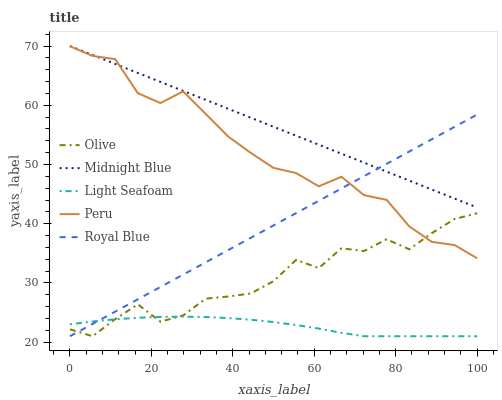Does Light Seafoam have the minimum area under the curve?
Answer yes or no. Yes. Does Midnight Blue have the maximum area under the curve?
Answer yes or no. Yes. Does Royal Blue have the minimum area under the curve?
Answer yes or no. No. Does Royal Blue have the maximum area under the curve?
Answer yes or no. No. Is Royal Blue the smoothest?
Answer yes or no. Yes. Is Olive the roughest?
Answer yes or no. Yes. Is Light Seafoam the smoothest?
Answer yes or no. No. Is Light Seafoam the roughest?
Answer yes or no. No. Does Olive have the lowest value?
Answer yes or no. Yes. Does Midnight Blue have the lowest value?
Answer yes or no. No. Does Midnight Blue have the highest value?
Answer yes or no. Yes. Does Royal Blue have the highest value?
Answer yes or no. No. Is Light Seafoam less than Midnight Blue?
Answer yes or no. Yes. Is Midnight Blue greater than Light Seafoam?
Answer yes or no. Yes. Does Midnight Blue intersect Peru?
Answer yes or no. Yes. Is Midnight Blue less than Peru?
Answer yes or no. No. Is Midnight Blue greater than Peru?
Answer yes or no. No. Does Light Seafoam intersect Midnight Blue?
Answer yes or no. No. 